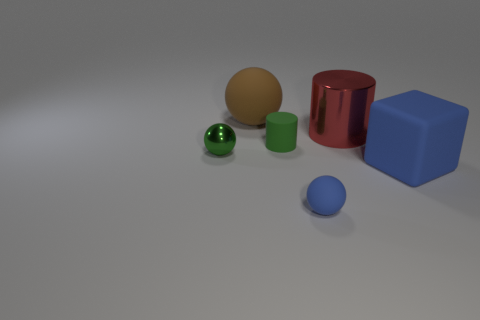Subtract all small balls. How many balls are left? 1 Subtract 2 spheres. How many spheres are left? 1 Subtract all red cylinders. How many cylinders are left? 1 Add 3 small green metallic balls. How many objects exist? 9 Subtract all yellow spheres. Subtract all brown blocks. How many spheres are left? 3 Subtract all cylinders. How many objects are left? 4 Subtract all spheres. Subtract all large red metal cylinders. How many objects are left? 2 Add 1 large blue rubber things. How many large blue rubber things are left? 2 Add 1 blocks. How many blocks exist? 2 Subtract 0 cyan balls. How many objects are left? 6 